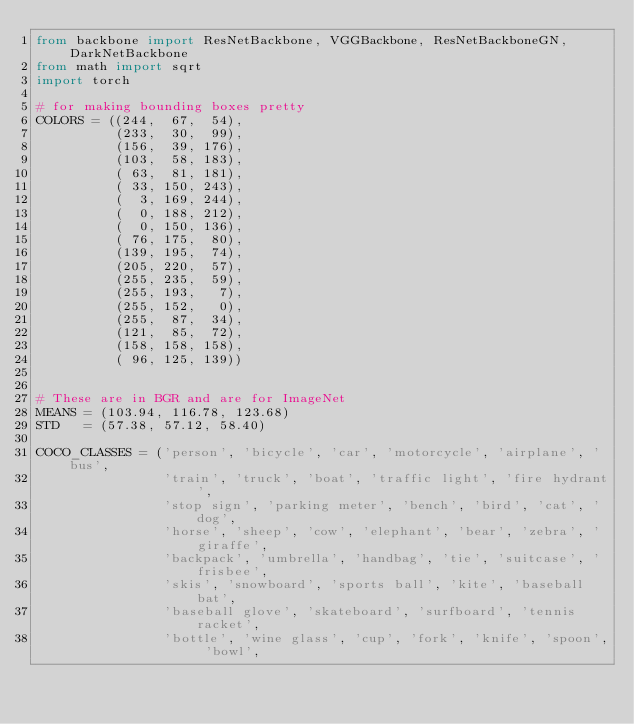<code> <loc_0><loc_0><loc_500><loc_500><_Python_>from backbone import ResNetBackbone, VGGBackbone, ResNetBackboneGN, DarkNetBackbone
from math import sqrt
import torch

# for making bounding boxes pretty
COLORS = ((244,  67,  54),
          (233,  30,  99),
          (156,  39, 176),
          (103,  58, 183),
          ( 63,  81, 181),
          ( 33, 150, 243),
          (  3, 169, 244),
          (  0, 188, 212),
          (  0, 150, 136),
          ( 76, 175,  80),
          (139, 195,  74),
          (205, 220,  57),
          (255, 235,  59),
          (255, 193,   7),
          (255, 152,   0),
          (255,  87,  34),
          (121,  85,  72),
          (158, 158, 158),
          ( 96, 125, 139))


# These are in BGR and are for ImageNet
MEANS = (103.94, 116.78, 123.68)
STD   = (57.38, 57.12, 58.40)

COCO_CLASSES = ('person', 'bicycle', 'car', 'motorcycle', 'airplane', 'bus',
                'train', 'truck', 'boat', 'traffic light', 'fire hydrant',
                'stop sign', 'parking meter', 'bench', 'bird', 'cat', 'dog',
                'horse', 'sheep', 'cow', 'elephant', 'bear', 'zebra', 'giraffe',
                'backpack', 'umbrella', 'handbag', 'tie', 'suitcase', 'frisbee',
                'skis', 'snowboard', 'sports ball', 'kite', 'baseball bat',
                'baseball glove', 'skateboard', 'surfboard', 'tennis racket',
                'bottle', 'wine glass', 'cup', 'fork', 'knife', 'spoon', 'bowl',</code> 